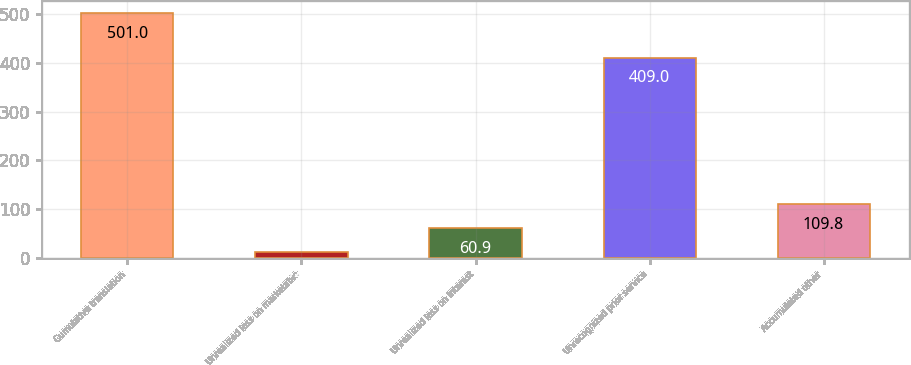<chart> <loc_0><loc_0><loc_500><loc_500><bar_chart><fcel>Cumulative translation<fcel>Unrealized loss on marketable<fcel>Unrealized loss on interest<fcel>Unrecognized prior service<fcel>Accumulated other<nl><fcel>501<fcel>12<fcel>60.9<fcel>409<fcel>109.8<nl></chart> 